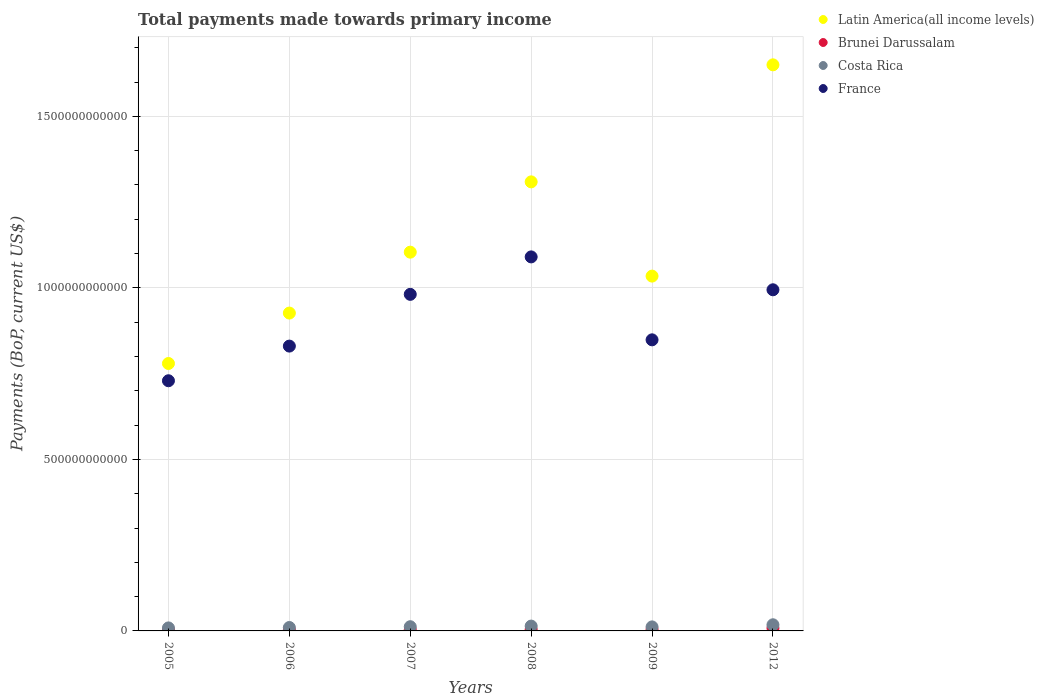How many different coloured dotlines are there?
Keep it short and to the point. 4. What is the total payments made towards primary income in Latin America(all income levels) in 2005?
Provide a short and direct response. 7.80e+11. Across all years, what is the maximum total payments made towards primary income in Brunei Darussalam?
Your response must be concise. 8.18e+09. Across all years, what is the minimum total payments made towards primary income in Brunei Darussalam?
Make the answer very short. 2.71e+09. In which year was the total payments made towards primary income in Costa Rica minimum?
Your answer should be compact. 2005. What is the total total payments made towards primary income in Costa Rica in the graph?
Offer a terse response. 7.48e+1. What is the difference between the total payments made towards primary income in Costa Rica in 2005 and that in 2006?
Provide a succinct answer. -1.19e+09. What is the difference between the total payments made towards primary income in Costa Rica in 2009 and the total payments made towards primary income in France in 2007?
Provide a short and direct response. -9.69e+11. What is the average total payments made towards primary income in Brunei Darussalam per year?
Ensure brevity in your answer.  4.31e+09. In the year 2006, what is the difference between the total payments made towards primary income in France and total payments made towards primary income in Costa Rica?
Provide a short and direct response. 8.20e+11. In how many years, is the total payments made towards primary income in Latin America(all income levels) greater than 900000000000 US$?
Give a very brief answer. 5. What is the ratio of the total payments made towards primary income in Costa Rica in 2007 to that in 2009?
Offer a terse response. 1.05. What is the difference between the highest and the second highest total payments made towards primary income in Costa Rica?
Give a very brief answer. 3.85e+09. What is the difference between the highest and the lowest total payments made towards primary income in France?
Offer a very short reply. 3.61e+11. Is it the case that in every year, the sum of the total payments made towards primary income in Costa Rica and total payments made towards primary income in Brunei Darussalam  is greater than the total payments made towards primary income in Latin America(all income levels)?
Your answer should be very brief. No. Does the total payments made towards primary income in France monotonically increase over the years?
Your answer should be very brief. No. Is the total payments made towards primary income in Latin America(all income levels) strictly greater than the total payments made towards primary income in Costa Rica over the years?
Keep it short and to the point. Yes. Is the total payments made towards primary income in France strictly less than the total payments made towards primary income in Latin America(all income levels) over the years?
Give a very brief answer. Yes. How many years are there in the graph?
Make the answer very short. 6. What is the difference between two consecutive major ticks on the Y-axis?
Offer a very short reply. 5.00e+11. Does the graph contain grids?
Keep it short and to the point. Yes. Where does the legend appear in the graph?
Keep it short and to the point. Top right. How are the legend labels stacked?
Your answer should be compact. Vertical. What is the title of the graph?
Keep it short and to the point. Total payments made towards primary income. Does "Rwanda" appear as one of the legend labels in the graph?
Offer a terse response. No. What is the label or title of the X-axis?
Make the answer very short. Years. What is the label or title of the Y-axis?
Ensure brevity in your answer.  Payments (BoP, current US$). What is the Payments (BoP, current US$) of Latin America(all income levels) in 2005?
Your answer should be compact. 7.80e+11. What is the Payments (BoP, current US$) of Brunei Darussalam in 2005?
Make the answer very short. 2.71e+09. What is the Payments (BoP, current US$) of Costa Rica in 2005?
Make the answer very short. 8.79e+09. What is the Payments (BoP, current US$) in France in 2005?
Keep it short and to the point. 7.29e+11. What is the Payments (BoP, current US$) of Latin America(all income levels) in 2006?
Provide a short and direct response. 9.27e+11. What is the Payments (BoP, current US$) in Brunei Darussalam in 2006?
Make the answer very short. 2.98e+09. What is the Payments (BoP, current US$) of Costa Rica in 2006?
Your answer should be compact. 9.98e+09. What is the Payments (BoP, current US$) in France in 2006?
Your answer should be compact. 8.30e+11. What is the Payments (BoP, current US$) in Latin America(all income levels) in 2007?
Your answer should be very brief. 1.10e+12. What is the Payments (BoP, current US$) of Brunei Darussalam in 2007?
Offer a terse response. 3.51e+09. What is the Payments (BoP, current US$) of Costa Rica in 2007?
Give a very brief answer. 1.23e+1. What is the Payments (BoP, current US$) in France in 2007?
Your response must be concise. 9.81e+11. What is the Payments (BoP, current US$) in Latin America(all income levels) in 2008?
Your answer should be compact. 1.31e+12. What is the Payments (BoP, current US$) in Brunei Darussalam in 2008?
Ensure brevity in your answer.  4.51e+09. What is the Payments (BoP, current US$) in Costa Rica in 2008?
Provide a succinct answer. 1.41e+1. What is the Payments (BoP, current US$) in France in 2008?
Provide a short and direct response. 1.09e+12. What is the Payments (BoP, current US$) in Latin America(all income levels) in 2009?
Your answer should be very brief. 1.03e+12. What is the Payments (BoP, current US$) in Brunei Darussalam in 2009?
Ensure brevity in your answer.  3.98e+09. What is the Payments (BoP, current US$) of Costa Rica in 2009?
Your answer should be very brief. 1.17e+1. What is the Payments (BoP, current US$) in France in 2009?
Offer a terse response. 8.49e+11. What is the Payments (BoP, current US$) in Latin America(all income levels) in 2012?
Give a very brief answer. 1.65e+12. What is the Payments (BoP, current US$) of Brunei Darussalam in 2012?
Offer a very short reply. 8.18e+09. What is the Payments (BoP, current US$) of Costa Rica in 2012?
Keep it short and to the point. 1.79e+1. What is the Payments (BoP, current US$) in France in 2012?
Offer a terse response. 9.95e+11. Across all years, what is the maximum Payments (BoP, current US$) in Latin America(all income levels)?
Give a very brief answer. 1.65e+12. Across all years, what is the maximum Payments (BoP, current US$) of Brunei Darussalam?
Your answer should be compact. 8.18e+09. Across all years, what is the maximum Payments (BoP, current US$) of Costa Rica?
Offer a terse response. 1.79e+1. Across all years, what is the maximum Payments (BoP, current US$) of France?
Offer a terse response. 1.09e+12. Across all years, what is the minimum Payments (BoP, current US$) in Latin America(all income levels)?
Ensure brevity in your answer.  7.80e+11. Across all years, what is the minimum Payments (BoP, current US$) of Brunei Darussalam?
Your response must be concise. 2.71e+09. Across all years, what is the minimum Payments (BoP, current US$) in Costa Rica?
Offer a terse response. 8.79e+09. Across all years, what is the minimum Payments (BoP, current US$) of France?
Your answer should be very brief. 7.29e+11. What is the total Payments (BoP, current US$) in Latin America(all income levels) in the graph?
Make the answer very short. 6.80e+12. What is the total Payments (BoP, current US$) of Brunei Darussalam in the graph?
Ensure brevity in your answer.  2.59e+1. What is the total Payments (BoP, current US$) of Costa Rica in the graph?
Make the answer very short. 7.48e+1. What is the total Payments (BoP, current US$) of France in the graph?
Make the answer very short. 5.47e+12. What is the difference between the Payments (BoP, current US$) in Latin America(all income levels) in 2005 and that in 2006?
Offer a terse response. -1.47e+11. What is the difference between the Payments (BoP, current US$) in Brunei Darussalam in 2005 and that in 2006?
Make the answer very short. -2.72e+08. What is the difference between the Payments (BoP, current US$) of Costa Rica in 2005 and that in 2006?
Provide a short and direct response. -1.19e+09. What is the difference between the Payments (BoP, current US$) of France in 2005 and that in 2006?
Your answer should be compact. -1.01e+11. What is the difference between the Payments (BoP, current US$) of Latin America(all income levels) in 2005 and that in 2007?
Offer a terse response. -3.25e+11. What is the difference between the Payments (BoP, current US$) in Brunei Darussalam in 2005 and that in 2007?
Your answer should be very brief. -8.03e+08. What is the difference between the Payments (BoP, current US$) of Costa Rica in 2005 and that in 2007?
Provide a succinct answer. -3.51e+09. What is the difference between the Payments (BoP, current US$) of France in 2005 and that in 2007?
Your response must be concise. -2.52e+11. What is the difference between the Payments (BoP, current US$) in Latin America(all income levels) in 2005 and that in 2008?
Your answer should be very brief. -5.29e+11. What is the difference between the Payments (BoP, current US$) in Brunei Darussalam in 2005 and that in 2008?
Give a very brief answer. -1.80e+09. What is the difference between the Payments (BoP, current US$) in Costa Rica in 2005 and that in 2008?
Your answer should be very brief. -5.31e+09. What is the difference between the Payments (BoP, current US$) in France in 2005 and that in 2008?
Offer a terse response. -3.61e+11. What is the difference between the Payments (BoP, current US$) in Latin America(all income levels) in 2005 and that in 2009?
Provide a succinct answer. -2.55e+11. What is the difference between the Payments (BoP, current US$) of Brunei Darussalam in 2005 and that in 2009?
Your answer should be very brief. -1.27e+09. What is the difference between the Payments (BoP, current US$) in Costa Rica in 2005 and that in 2009?
Give a very brief answer. -2.93e+09. What is the difference between the Payments (BoP, current US$) of France in 2005 and that in 2009?
Provide a succinct answer. -1.19e+11. What is the difference between the Payments (BoP, current US$) in Latin America(all income levels) in 2005 and that in 2012?
Offer a terse response. -8.71e+11. What is the difference between the Payments (BoP, current US$) in Brunei Darussalam in 2005 and that in 2012?
Ensure brevity in your answer.  -5.47e+09. What is the difference between the Payments (BoP, current US$) in Costa Rica in 2005 and that in 2012?
Your answer should be compact. -9.15e+09. What is the difference between the Payments (BoP, current US$) in France in 2005 and that in 2012?
Make the answer very short. -2.65e+11. What is the difference between the Payments (BoP, current US$) of Latin America(all income levels) in 2006 and that in 2007?
Offer a terse response. -1.78e+11. What is the difference between the Payments (BoP, current US$) in Brunei Darussalam in 2006 and that in 2007?
Make the answer very short. -5.30e+08. What is the difference between the Payments (BoP, current US$) of Costa Rica in 2006 and that in 2007?
Your answer should be compact. -2.32e+09. What is the difference between the Payments (BoP, current US$) of France in 2006 and that in 2007?
Make the answer very short. -1.51e+11. What is the difference between the Payments (BoP, current US$) in Latin America(all income levels) in 2006 and that in 2008?
Provide a short and direct response. -3.82e+11. What is the difference between the Payments (BoP, current US$) of Brunei Darussalam in 2006 and that in 2008?
Ensure brevity in your answer.  -1.52e+09. What is the difference between the Payments (BoP, current US$) in Costa Rica in 2006 and that in 2008?
Offer a very short reply. -4.12e+09. What is the difference between the Payments (BoP, current US$) in France in 2006 and that in 2008?
Your response must be concise. -2.60e+11. What is the difference between the Payments (BoP, current US$) in Latin America(all income levels) in 2006 and that in 2009?
Keep it short and to the point. -1.08e+11. What is the difference between the Payments (BoP, current US$) in Brunei Darussalam in 2006 and that in 2009?
Offer a terse response. -9.96e+08. What is the difference between the Payments (BoP, current US$) in Costa Rica in 2006 and that in 2009?
Your answer should be compact. -1.74e+09. What is the difference between the Payments (BoP, current US$) of France in 2006 and that in 2009?
Offer a terse response. -1.83e+1. What is the difference between the Payments (BoP, current US$) of Latin America(all income levels) in 2006 and that in 2012?
Provide a short and direct response. -7.24e+11. What is the difference between the Payments (BoP, current US$) in Brunei Darussalam in 2006 and that in 2012?
Offer a very short reply. -5.20e+09. What is the difference between the Payments (BoP, current US$) in Costa Rica in 2006 and that in 2012?
Make the answer very short. -7.96e+09. What is the difference between the Payments (BoP, current US$) of France in 2006 and that in 2012?
Your answer should be compact. -1.64e+11. What is the difference between the Payments (BoP, current US$) in Latin America(all income levels) in 2007 and that in 2008?
Your answer should be very brief. -2.05e+11. What is the difference between the Payments (BoP, current US$) in Brunei Darussalam in 2007 and that in 2008?
Make the answer very short. -9.95e+08. What is the difference between the Payments (BoP, current US$) of Costa Rica in 2007 and that in 2008?
Your response must be concise. -1.79e+09. What is the difference between the Payments (BoP, current US$) in France in 2007 and that in 2008?
Give a very brief answer. -1.09e+11. What is the difference between the Payments (BoP, current US$) of Latin America(all income levels) in 2007 and that in 2009?
Your response must be concise. 6.98e+1. What is the difference between the Payments (BoP, current US$) of Brunei Darussalam in 2007 and that in 2009?
Provide a short and direct response. -4.66e+08. What is the difference between the Payments (BoP, current US$) of Costa Rica in 2007 and that in 2009?
Provide a short and direct response. 5.80e+08. What is the difference between the Payments (BoP, current US$) of France in 2007 and that in 2009?
Your answer should be very brief. 1.33e+11. What is the difference between the Payments (BoP, current US$) in Latin America(all income levels) in 2007 and that in 2012?
Keep it short and to the point. -5.46e+11. What is the difference between the Payments (BoP, current US$) in Brunei Darussalam in 2007 and that in 2012?
Keep it short and to the point. -4.67e+09. What is the difference between the Payments (BoP, current US$) of Costa Rica in 2007 and that in 2012?
Offer a very short reply. -5.64e+09. What is the difference between the Payments (BoP, current US$) in France in 2007 and that in 2012?
Your answer should be compact. -1.33e+1. What is the difference between the Payments (BoP, current US$) in Latin America(all income levels) in 2008 and that in 2009?
Provide a short and direct response. 2.75e+11. What is the difference between the Payments (BoP, current US$) in Brunei Darussalam in 2008 and that in 2009?
Give a very brief answer. 5.28e+08. What is the difference between the Payments (BoP, current US$) of Costa Rica in 2008 and that in 2009?
Ensure brevity in your answer.  2.37e+09. What is the difference between the Payments (BoP, current US$) of France in 2008 and that in 2009?
Your response must be concise. 2.42e+11. What is the difference between the Payments (BoP, current US$) of Latin America(all income levels) in 2008 and that in 2012?
Your answer should be very brief. -3.41e+11. What is the difference between the Payments (BoP, current US$) of Brunei Darussalam in 2008 and that in 2012?
Your answer should be compact. -3.67e+09. What is the difference between the Payments (BoP, current US$) in Costa Rica in 2008 and that in 2012?
Provide a short and direct response. -3.85e+09. What is the difference between the Payments (BoP, current US$) in France in 2008 and that in 2012?
Provide a succinct answer. 9.59e+1. What is the difference between the Payments (BoP, current US$) in Latin America(all income levels) in 2009 and that in 2012?
Give a very brief answer. -6.16e+11. What is the difference between the Payments (BoP, current US$) in Brunei Darussalam in 2009 and that in 2012?
Keep it short and to the point. -4.20e+09. What is the difference between the Payments (BoP, current US$) in Costa Rica in 2009 and that in 2012?
Provide a short and direct response. -6.22e+09. What is the difference between the Payments (BoP, current US$) of France in 2009 and that in 2012?
Offer a very short reply. -1.46e+11. What is the difference between the Payments (BoP, current US$) in Latin America(all income levels) in 2005 and the Payments (BoP, current US$) in Brunei Darussalam in 2006?
Give a very brief answer. 7.77e+11. What is the difference between the Payments (BoP, current US$) of Latin America(all income levels) in 2005 and the Payments (BoP, current US$) of Costa Rica in 2006?
Ensure brevity in your answer.  7.70e+11. What is the difference between the Payments (BoP, current US$) in Latin America(all income levels) in 2005 and the Payments (BoP, current US$) in France in 2006?
Your answer should be compact. -5.07e+1. What is the difference between the Payments (BoP, current US$) in Brunei Darussalam in 2005 and the Payments (BoP, current US$) in Costa Rica in 2006?
Provide a short and direct response. -7.26e+09. What is the difference between the Payments (BoP, current US$) of Brunei Darussalam in 2005 and the Payments (BoP, current US$) of France in 2006?
Ensure brevity in your answer.  -8.28e+11. What is the difference between the Payments (BoP, current US$) in Costa Rica in 2005 and the Payments (BoP, current US$) in France in 2006?
Offer a very short reply. -8.22e+11. What is the difference between the Payments (BoP, current US$) of Latin America(all income levels) in 2005 and the Payments (BoP, current US$) of Brunei Darussalam in 2007?
Make the answer very short. 7.76e+11. What is the difference between the Payments (BoP, current US$) of Latin America(all income levels) in 2005 and the Payments (BoP, current US$) of Costa Rica in 2007?
Provide a succinct answer. 7.67e+11. What is the difference between the Payments (BoP, current US$) of Latin America(all income levels) in 2005 and the Payments (BoP, current US$) of France in 2007?
Provide a short and direct response. -2.02e+11. What is the difference between the Payments (BoP, current US$) in Brunei Darussalam in 2005 and the Payments (BoP, current US$) in Costa Rica in 2007?
Ensure brevity in your answer.  -9.59e+09. What is the difference between the Payments (BoP, current US$) of Brunei Darussalam in 2005 and the Payments (BoP, current US$) of France in 2007?
Your response must be concise. -9.78e+11. What is the difference between the Payments (BoP, current US$) in Costa Rica in 2005 and the Payments (BoP, current US$) in France in 2007?
Your answer should be compact. -9.72e+11. What is the difference between the Payments (BoP, current US$) of Latin America(all income levels) in 2005 and the Payments (BoP, current US$) of Brunei Darussalam in 2008?
Make the answer very short. 7.75e+11. What is the difference between the Payments (BoP, current US$) in Latin America(all income levels) in 2005 and the Payments (BoP, current US$) in Costa Rica in 2008?
Ensure brevity in your answer.  7.66e+11. What is the difference between the Payments (BoP, current US$) in Latin America(all income levels) in 2005 and the Payments (BoP, current US$) in France in 2008?
Your answer should be very brief. -3.11e+11. What is the difference between the Payments (BoP, current US$) of Brunei Darussalam in 2005 and the Payments (BoP, current US$) of Costa Rica in 2008?
Make the answer very short. -1.14e+1. What is the difference between the Payments (BoP, current US$) in Brunei Darussalam in 2005 and the Payments (BoP, current US$) in France in 2008?
Provide a succinct answer. -1.09e+12. What is the difference between the Payments (BoP, current US$) of Costa Rica in 2005 and the Payments (BoP, current US$) of France in 2008?
Your response must be concise. -1.08e+12. What is the difference between the Payments (BoP, current US$) of Latin America(all income levels) in 2005 and the Payments (BoP, current US$) of Brunei Darussalam in 2009?
Keep it short and to the point. 7.76e+11. What is the difference between the Payments (BoP, current US$) of Latin America(all income levels) in 2005 and the Payments (BoP, current US$) of Costa Rica in 2009?
Provide a short and direct response. 7.68e+11. What is the difference between the Payments (BoP, current US$) of Latin America(all income levels) in 2005 and the Payments (BoP, current US$) of France in 2009?
Ensure brevity in your answer.  -6.90e+1. What is the difference between the Payments (BoP, current US$) of Brunei Darussalam in 2005 and the Payments (BoP, current US$) of Costa Rica in 2009?
Your response must be concise. -9.01e+09. What is the difference between the Payments (BoP, current US$) in Brunei Darussalam in 2005 and the Payments (BoP, current US$) in France in 2009?
Offer a terse response. -8.46e+11. What is the difference between the Payments (BoP, current US$) of Costa Rica in 2005 and the Payments (BoP, current US$) of France in 2009?
Make the answer very short. -8.40e+11. What is the difference between the Payments (BoP, current US$) in Latin America(all income levels) in 2005 and the Payments (BoP, current US$) in Brunei Darussalam in 2012?
Your answer should be compact. 7.71e+11. What is the difference between the Payments (BoP, current US$) of Latin America(all income levels) in 2005 and the Payments (BoP, current US$) of Costa Rica in 2012?
Give a very brief answer. 7.62e+11. What is the difference between the Payments (BoP, current US$) in Latin America(all income levels) in 2005 and the Payments (BoP, current US$) in France in 2012?
Offer a terse response. -2.15e+11. What is the difference between the Payments (BoP, current US$) of Brunei Darussalam in 2005 and the Payments (BoP, current US$) of Costa Rica in 2012?
Offer a very short reply. -1.52e+1. What is the difference between the Payments (BoP, current US$) of Brunei Darussalam in 2005 and the Payments (BoP, current US$) of France in 2012?
Ensure brevity in your answer.  -9.92e+11. What is the difference between the Payments (BoP, current US$) in Costa Rica in 2005 and the Payments (BoP, current US$) in France in 2012?
Make the answer very short. -9.86e+11. What is the difference between the Payments (BoP, current US$) in Latin America(all income levels) in 2006 and the Payments (BoP, current US$) in Brunei Darussalam in 2007?
Give a very brief answer. 9.23e+11. What is the difference between the Payments (BoP, current US$) of Latin America(all income levels) in 2006 and the Payments (BoP, current US$) of Costa Rica in 2007?
Provide a succinct answer. 9.14e+11. What is the difference between the Payments (BoP, current US$) in Latin America(all income levels) in 2006 and the Payments (BoP, current US$) in France in 2007?
Offer a terse response. -5.45e+1. What is the difference between the Payments (BoP, current US$) of Brunei Darussalam in 2006 and the Payments (BoP, current US$) of Costa Rica in 2007?
Your response must be concise. -9.32e+09. What is the difference between the Payments (BoP, current US$) of Brunei Darussalam in 2006 and the Payments (BoP, current US$) of France in 2007?
Offer a terse response. -9.78e+11. What is the difference between the Payments (BoP, current US$) of Costa Rica in 2006 and the Payments (BoP, current US$) of France in 2007?
Give a very brief answer. -9.71e+11. What is the difference between the Payments (BoP, current US$) in Latin America(all income levels) in 2006 and the Payments (BoP, current US$) in Brunei Darussalam in 2008?
Give a very brief answer. 9.22e+11. What is the difference between the Payments (BoP, current US$) of Latin America(all income levels) in 2006 and the Payments (BoP, current US$) of Costa Rica in 2008?
Offer a terse response. 9.13e+11. What is the difference between the Payments (BoP, current US$) of Latin America(all income levels) in 2006 and the Payments (BoP, current US$) of France in 2008?
Your answer should be very brief. -1.64e+11. What is the difference between the Payments (BoP, current US$) in Brunei Darussalam in 2006 and the Payments (BoP, current US$) in Costa Rica in 2008?
Your answer should be compact. -1.11e+1. What is the difference between the Payments (BoP, current US$) in Brunei Darussalam in 2006 and the Payments (BoP, current US$) in France in 2008?
Your answer should be very brief. -1.09e+12. What is the difference between the Payments (BoP, current US$) of Costa Rica in 2006 and the Payments (BoP, current US$) of France in 2008?
Your answer should be very brief. -1.08e+12. What is the difference between the Payments (BoP, current US$) in Latin America(all income levels) in 2006 and the Payments (BoP, current US$) in Brunei Darussalam in 2009?
Ensure brevity in your answer.  9.23e+11. What is the difference between the Payments (BoP, current US$) of Latin America(all income levels) in 2006 and the Payments (BoP, current US$) of Costa Rica in 2009?
Give a very brief answer. 9.15e+11. What is the difference between the Payments (BoP, current US$) in Latin America(all income levels) in 2006 and the Payments (BoP, current US$) in France in 2009?
Offer a terse response. 7.80e+1. What is the difference between the Payments (BoP, current US$) of Brunei Darussalam in 2006 and the Payments (BoP, current US$) of Costa Rica in 2009?
Provide a short and direct response. -8.74e+09. What is the difference between the Payments (BoP, current US$) in Brunei Darussalam in 2006 and the Payments (BoP, current US$) in France in 2009?
Offer a terse response. -8.46e+11. What is the difference between the Payments (BoP, current US$) in Costa Rica in 2006 and the Payments (BoP, current US$) in France in 2009?
Make the answer very short. -8.39e+11. What is the difference between the Payments (BoP, current US$) of Latin America(all income levels) in 2006 and the Payments (BoP, current US$) of Brunei Darussalam in 2012?
Make the answer very short. 9.18e+11. What is the difference between the Payments (BoP, current US$) of Latin America(all income levels) in 2006 and the Payments (BoP, current US$) of Costa Rica in 2012?
Offer a terse response. 9.09e+11. What is the difference between the Payments (BoP, current US$) of Latin America(all income levels) in 2006 and the Payments (BoP, current US$) of France in 2012?
Your answer should be compact. -6.79e+1. What is the difference between the Payments (BoP, current US$) of Brunei Darussalam in 2006 and the Payments (BoP, current US$) of Costa Rica in 2012?
Ensure brevity in your answer.  -1.50e+1. What is the difference between the Payments (BoP, current US$) of Brunei Darussalam in 2006 and the Payments (BoP, current US$) of France in 2012?
Your response must be concise. -9.92e+11. What is the difference between the Payments (BoP, current US$) in Costa Rica in 2006 and the Payments (BoP, current US$) in France in 2012?
Offer a terse response. -9.85e+11. What is the difference between the Payments (BoP, current US$) in Latin America(all income levels) in 2007 and the Payments (BoP, current US$) in Brunei Darussalam in 2008?
Your response must be concise. 1.10e+12. What is the difference between the Payments (BoP, current US$) of Latin America(all income levels) in 2007 and the Payments (BoP, current US$) of Costa Rica in 2008?
Ensure brevity in your answer.  1.09e+12. What is the difference between the Payments (BoP, current US$) in Latin America(all income levels) in 2007 and the Payments (BoP, current US$) in France in 2008?
Make the answer very short. 1.38e+1. What is the difference between the Payments (BoP, current US$) of Brunei Darussalam in 2007 and the Payments (BoP, current US$) of Costa Rica in 2008?
Offer a very short reply. -1.06e+1. What is the difference between the Payments (BoP, current US$) of Brunei Darussalam in 2007 and the Payments (BoP, current US$) of France in 2008?
Your answer should be compact. -1.09e+12. What is the difference between the Payments (BoP, current US$) of Costa Rica in 2007 and the Payments (BoP, current US$) of France in 2008?
Ensure brevity in your answer.  -1.08e+12. What is the difference between the Payments (BoP, current US$) in Latin America(all income levels) in 2007 and the Payments (BoP, current US$) in Brunei Darussalam in 2009?
Offer a terse response. 1.10e+12. What is the difference between the Payments (BoP, current US$) of Latin America(all income levels) in 2007 and the Payments (BoP, current US$) of Costa Rica in 2009?
Keep it short and to the point. 1.09e+12. What is the difference between the Payments (BoP, current US$) in Latin America(all income levels) in 2007 and the Payments (BoP, current US$) in France in 2009?
Keep it short and to the point. 2.56e+11. What is the difference between the Payments (BoP, current US$) in Brunei Darussalam in 2007 and the Payments (BoP, current US$) in Costa Rica in 2009?
Offer a terse response. -8.21e+09. What is the difference between the Payments (BoP, current US$) of Brunei Darussalam in 2007 and the Payments (BoP, current US$) of France in 2009?
Your answer should be compact. -8.45e+11. What is the difference between the Payments (BoP, current US$) of Costa Rica in 2007 and the Payments (BoP, current US$) of France in 2009?
Provide a succinct answer. -8.36e+11. What is the difference between the Payments (BoP, current US$) in Latin America(all income levels) in 2007 and the Payments (BoP, current US$) in Brunei Darussalam in 2012?
Provide a short and direct response. 1.10e+12. What is the difference between the Payments (BoP, current US$) of Latin America(all income levels) in 2007 and the Payments (BoP, current US$) of Costa Rica in 2012?
Provide a short and direct response. 1.09e+12. What is the difference between the Payments (BoP, current US$) in Latin America(all income levels) in 2007 and the Payments (BoP, current US$) in France in 2012?
Offer a very short reply. 1.10e+11. What is the difference between the Payments (BoP, current US$) in Brunei Darussalam in 2007 and the Payments (BoP, current US$) in Costa Rica in 2012?
Make the answer very short. -1.44e+1. What is the difference between the Payments (BoP, current US$) of Brunei Darussalam in 2007 and the Payments (BoP, current US$) of France in 2012?
Make the answer very short. -9.91e+11. What is the difference between the Payments (BoP, current US$) of Costa Rica in 2007 and the Payments (BoP, current US$) of France in 2012?
Offer a very short reply. -9.82e+11. What is the difference between the Payments (BoP, current US$) in Latin America(all income levels) in 2008 and the Payments (BoP, current US$) in Brunei Darussalam in 2009?
Your answer should be very brief. 1.31e+12. What is the difference between the Payments (BoP, current US$) of Latin America(all income levels) in 2008 and the Payments (BoP, current US$) of Costa Rica in 2009?
Keep it short and to the point. 1.30e+12. What is the difference between the Payments (BoP, current US$) of Latin America(all income levels) in 2008 and the Payments (BoP, current US$) of France in 2009?
Offer a very short reply. 4.61e+11. What is the difference between the Payments (BoP, current US$) of Brunei Darussalam in 2008 and the Payments (BoP, current US$) of Costa Rica in 2009?
Your answer should be very brief. -7.21e+09. What is the difference between the Payments (BoP, current US$) in Brunei Darussalam in 2008 and the Payments (BoP, current US$) in France in 2009?
Offer a very short reply. -8.44e+11. What is the difference between the Payments (BoP, current US$) of Costa Rica in 2008 and the Payments (BoP, current US$) of France in 2009?
Your answer should be very brief. -8.34e+11. What is the difference between the Payments (BoP, current US$) in Latin America(all income levels) in 2008 and the Payments (BoP, current US$) in Brunei Darussalam in 2012?
Make the answer very short. 1.30e+12. What is the difference between the Payments (BoP, current US$) of Latin America(all income levels) in 2008 and the Payments (BoP, current US$) of Costa Rica in 2012?
Give a very brief answer. 1.29e+12. What is the difference between the Payments (BoP, current US$) in Latin America(all income levels) in 2008 and the Payments (BoP, current US$) in France in 2012?
Ensure brevity in your answer.  3.15e+11. What is the difference between the Payments (BoP, current US$) in Brunei Darussalam in 2008 and the Payments (BoP, current US$) in Costa Rica in 2012?
Your response must be concise. -1.34e+1. What is the difference between the Payments (BoP, current US$) of Brunei Darussalam in 2008 and the Payments (BoP, current US$) of France in 2012?
Provide a short and direct response. -9.90e+11. What is the difference between the Payments (BoP, current US$) in Costa Rica in 2008 and the Payments (BoP, current US$) in France in 2012?
Your response must be concise. -9.80e+11. What is the difference between the Payments (BoP, current US$) of Latin America(all income levels) in 2009 and the Payments (BoP, current US$) of Brunei Darussalam in 2012?
Keep it short and to the point. 1.03e+12. What is the difference between the Payments (BoP, current US$) in Latin America(all income levels) in 2009 and the Payments (BoP, current US$) in Costa Rica in 2012?
Your answer should be compact. 1.02e+12. What is the difference between the Payments (BoP, current US$) in Latin America(all income levels) in 2009 and the Payments (BoP, current US$) in France in 2012?
Make the answer very short. 3.99e+1. What is the difference between the Payments (BoP, current US$) in Brunei Darussalam in 2009 and the Payments (BoP, current US$) in Costa Rica in 2012?
Keep it short and to the point. -1.40e+1. What is the difference between the Payments (BoP, current US$) of Brunei Darussalam in 2009 and the Payments (BoP, current US$) of France in 2012?
Provide a short and direct response. -9.91e+11. What is the difference between the Payments (BoP, current US$) of Costa Rica in 2009 and the Payments (BoP, current US$) of France in 2012?
Your answer should be very brief. -9.83e+11. What is the average Payments (BoP, current US$) in Latin America(all income levels) per year?
Your answer should be compact. 1.13e+12. What is the average Payments (BoP, current US$) of Brunei Darussalam per year?
Your response must be concise. 4.31e+09. What is the average Payments (BoP, current US$) of Costa Rica per year?
Make the answer very short. 1.25e+1. What is the average Payments (BoP, current US$) in France per year?
Ensure brevity in your answer.  9.12e+11. In the year 2005, what is the difference between the Payments (BoP, current US$) of Latin America(all income levels) and Payments (BoP, current US$) of Brunei Darussalam?
Offer a terse response. 7.77e+11. In the year 2005, what is the difference between the Payments (BoP, current US$) in Latin America(all income levels) and Payments (BoP, current US$) in Costa Rica?
Provide a short and direct response. 7.71e+11. In the year 2005, what is the difference between the Payments (BoP, current US$) of Latin America(all income levels) and Payments (BoP, current US$) of France?
Keep it short and to the point. 5.03e+1. In the year 2005, what is the difference between the Payments (BoP, current US$) of Brunei Darussalam and Payments (BoP, current US$) of Costa Rica?
Make the answer very short. -6.07e+09. In the year 2005, what is the difference between the Payments (BoP, current US$) in Brunei Darussalam and Payments (BoP, current US$) in France?
Offer a terse response. -7.27e+11. In the year 2005, what is the difference between the Payments (BoP, current US$) in Costa Rica and Payments (BoP, current US$) in France?
Your response must be concise. -7.21e+11. In the year 2006, what is the difference between the Payments (BoP, current US$) of Latin America(all income levels) and Payments (BoP, current US$) of Brunei Darussalam?
Your response must be concise. 9.24e+11. In the year 2006, what is the difference between the Payments (BoP, current US$) of Latin America(all income levels) and Payments (BoP, current US$) of Costa Rica?
Keep it short and to the point. 9.17e+11. In the year 2006, what is the difference between the Payments (BoP, current US$) in Latin America(all income levels) and Payments (BoP, current US$) in France?
Offer a very short reply. 9.63e+1. In the year 2006, what is the difference between the Payments (BoP, current US$) in Brunei Darussalam and Payments (BoP, current US$) in Costa Rica?
Ensure brevity in your answer.  -6.99e+09. In the year 2006, what is the difference between the Payments (BoP, current US$) in Brunei Darussalam and Payments (BoP, current US$) in France?
Keep it short and to the point. -8.27e+11. In the year 2006, what is the difference between the Payments (BoP, current US$) of Costa Rica and Payments (BoP, current US$) of France?
Give a very brief answer. -8.20e+11. In the year 2007, what is the difference between the Payments (BoP, current US$) in Latin America(all income levels) and Payments (BoP, current US$) in Brunei Darussalam?
Your answer should be very brief. 1.10e+12. In the year 2007, what is the difference between the Payments (BoP, current US$) of Latin America(all income levels) and Payments (BoP, current US$) of Costa Rica?
Make the answer very short. 1.09e+12. In the year 2007, what is the difference between the Payments (BoP, current US$) in Latin America(all income levels) and Payments (BoP, current US$) in France?
Provide a succinct answer. 1.23e+11. In the year 2007, what is the difference between the Payments (BoP, current US$) in Brunei Darussalam and Payments (BoP, current US$) in Costa Rica?
Offer a very short reply. -8.79e+09. In the year 2007, what is the difference between the Payments (BoP, current US$) in Brunei Darussalam and Payments (BoP, current US$) in France?
Your answer should be compact. -9.78e+11. In the year 2007, what is the difference between the Payments (BoP, current US$) in Costa Rica and Payments (BoP, current US$) in France?
Your response must be concise. -9.69e+11. In the year 2008, what is the difference between the Payments (BoP, current US$) of Latin America(all income levels) and Payments (BoP, current US$) of Brunei Darussalam?
Ensure brevity in your answer.  1.30e+12. In the year 2008, what is the difference between the Payments (BoP, current US$) of Latin America(all income levels) and Payments (BoP, current US$) of Costa Rica?
Keep it short and to the point. 1.30e+12. In the year 2008, what is the difference between the Payments (BoP, current US$) in Latin America(all income levels) and Payments (BoP, current US$) in France?
Offer a terse response. 2.19e+11. In the year 2008, what is the difference between the Payments (BoP, current US$) in Brunei Darussalam and Payments (BoP, current US$) in Costa Rica?
Your answer should be very brief. -9.58e+09. In the year 2008, what is the difference between the Payments (BoP, current US$) in Brunei Darussalam and Payments (BoP, current US$) in France?
Offer a very short reply. -1.09e+12. In the year 2008, what is the difference between the Payments (BoP, current US$) of Costa Rica and Payments (BoP, current US$) of France?
Keep it short and to the point. -1.08e+12. In the year 2009, what is the difference between the Payments (BoP, current US$) of Latin America(all income levels) and Payments (BoP, current US$) of Brunei Darussalam?
Your response must be concise. 1.03e+12. In the year 2009, what is the difference between the Payments (BoP, current US$) of Latin America(all income levels) and Payments (BoP, current US$) of Costa Rica?
Offer a very short reply. 1.02e+12. In the year 2009, what is the difference between the Payments (BoP, current US$) of Latin America(all income levels) and Payments (BoP, current US$) of France?
Your answer should be very brief. 1.86e+11. In the year 2009, what is the difference between the Payments (BoP, current US$) in Brunei Darussalam and Payments (BoP, current US$) in Costa Rica?
Give a very brief answer. -7.74e+09. In the year 2009, what is the difference between the Payments (BoP, current US$) in Brunei Darussalam and Payments (BoP, current US$) in France?
Offer a terse response. -8.45e+11. In the year 2009, what is the difference between the Payments (BoP, current US$) in Costa Rica and Payments (BoP, current US$) in France?
Your response must be concise. -8.37e+11. In the year 2012, what is the difference between the Payments (BoP, current US$) in Latin America(all income levels) and Payments (BoP, current US$) in Brunei Darussalam?
Ensure brevity in your answer.  1.64e+12. In the year 2012, what is the difference between the Payments (BoP, current US$) in Latin America(all income levels) and Payments (BoP, current US$) in Costa Rica?
Make the answer very short. 1.63e+12. In the year 2012, what is the difference between the Payments (BoP, current US$) of Latin America(all income levels) and Payments (BoP, current US$) of France?
Keep it short and to the point. 6.56e+11. In the year 2012, what is the difference between the Payments (BoP, current US$) of Brunei Darussalam and Payments (BoP, current US$) of Costa Rica?
Keep it short and to the point. -9.76e+09. In the year 2012, what is the difference between the Payments (BoP, current US$) of Brunei Darussalam and Payments (BoP, current US$) of France?
Offer a terse response. -9.86e+11. In the year 2012, what is the difference between the Payments (BoP, current US$) in Costa Rica and Payments (BoP, current US$) in France?
Give a very brief answer. -9.77e+11. What is the ratio of the Payments (BoP, current US$) in Latin America(all income levels) in 2005 to that in 2006?
Offer a terse response. 0.84. What is the ratio of the Payments (BoP, current US$) in Brunei Darussalam in 2005 to that in 2006?
Your answer should be very brief. 0.91. What is the ratio of the Payments (BoP, current US$) in Costa Rica in 2005 to that in 2006?
Give a very brief answer. 0.88. What is the ratio of the Payments (BoP, current US$) in France in 2005 to that in 2006?
Offer a terse response. 0.88. What is the ratio of the Payments (BoP, current US$) in Latin America(all income levels) in 2005 to that in 2007?
Provide a succinct answer. 0.71. What is the ratio of the Payments (BoP, current US$) in Brunei Darussalam in 2005 to that in 2007?
Provide a short and direct response. 0.77. What is the ratio of the Payments (BoP, current US$) of Costa Rica in 2005 to that in 2007?
Your response must be concise. 0.71. What is the ratio of the Payments (BoP, current US$) of France in 2005 to that in 2007?
Keep it short and to the point. 0.74. What is the ratio of the Payments (BoP, current US$) of Latin America(all income levels) in 2005 to that in 2008?
Your answer should be compact. 0.6. What is the ratio of the Payments (BoP, current US$) of Brunei Darussalam in 2005 to that in 2008?
Your response must be concise. 0.6. What is the ratio of the Payments (BoP, current US$) in Costa Rica in 2005 to that in 2008?
Your answer should be compact. 0.62. What is the ratio of the Payments (BoP, current US$) of France in 2005 to that in 2008?
Give a very brief answer. 0.67. What is the ratio of the Payments (BoP, current US$) in Latin America(all income levels) in 2005 to that in 2009?
Provide a succinct answer. 0.75. What is the ratio of the Payments (BoP, current US$) in Brunei Darussalam in 2005 to that in 2009?
Ensure brevity in your answer.  0.68. What is the ratio of the Payments (BoP, current US$) of Costa Rica in 2005 to that in 2009?
Your answer should be compact. 0.75. What is the ratio of the Payments (BoP, current US$) in France in 2005 to that in 2009?
Ensure brevity in your answer.  0.86. What is the ratio of the Payments (BoP, current US$) of Latin America(all income levels) in 2005 to that in 2012?
Ensure brevity in your answer.  0.47. What is the ratio of the Payments (BoP, current US$) in Brunei Darussalam in 2005 to that in 2012?
Offer a terse response. 0.33. What is the ratio of the Payments (BoP, current US$) of Costa Rica in 2005 to that in 2012?
Provide a succinct answer. 0.49. What is the ratio of the Payments (BoP, current US$) of France in 2005 to that in 2012?
Keep it short and to the point. 0.73. What is the ratio of the Payments (BoP, current US$) of Latin America(all income levels) in 2006 to that in 2007?
Provide a succinct answer. 0.84. What is the ratio of the Payments (BoP, current US$) of Brunei Darussalam in 2006 to that in 2007?
Provide a short and direct response. 0.85. What is the ratio of the Payments (BoP, current US$) in Costa Rica in 2006 to that in 2007?
Keep it short and to the point. 0.81. What is the ratio of the Payments (BoP, current US$) in France in 2006 to that in 2007?
Offer a terse response. 0.85. What is the ratio of the Payments (BoP, current US$) in Latin America(all income levels) in 2006 to that in 2008?
Keep it short and to the point. 0.71. What is the ratio of the Payments (BoP, current US$) of Brunei Darussalam in 2006 to that in 2008?
Ensure brevity in your answer.  0.66. What is the ratio of the Payments (BoP, current US$) in Costa Rica in 2006 to that in 2008?
Keep it short and to the point. 0.71. What is the ratio of the Payments (BoP, current US$) in France in 2006 to that in 2008?
Offer a terse response. 0.76. What is the ratio of the Payments (BoP, current US$) of Latin America(all income levels) in 2006 to that in 2009?
Make the answer very short. 0.9. What is the ratio of the Payments (BoP, current US$) of Brunei Darussalam in 2006 to that in 2009?
Your response must be concise. 0.75. What is the ratio of the Payments (BoP, current US$) in Costa Rica in 2006 to that in 2009?
Keep it short and to the point. 0.85. What is the ratio of the Payments (BoP, current US$) in France in 2006 to that in 2009?
Ensure brevity in your answer.  0.98. What is the ratio of the Payments (BoP, current US$) in Latin America(all income levels) in 2006 to that in 2012?
Provide a short and direct response. 0.56. What is the ratio of the Payments (BoP, current US$) in Brunei Darussalam in 2006 to that in 2012?
Make the answer very short. 0.36. What is the ratio of the Payments (BoP, current US$) of Costa Rica in 2006 to that in 2012?
Offer a very short reply. 0.56. What is the ratio of the Payments (BoP, current US$) in France in 2006 to that in 2012?
Your answer should be very brief. 0.83. What is the ratio of the Payments (BoP, current US$) in Latin America(all income levels) in 2007 to that in 2008?
Your answer should be very brief. 0.84. What is the ratio of the Payments (BoP, current US$) in Brunei Darussalam in 2007 to that in 2008?
Provide a succinct answer. 0.78. What is the ratio of the Payments (BoP, current US$) in Costa Rica in 2007 to that in 2008?
Keep it short and to the point. 0.87. What is the ratio of the Payments (BoP, current US$) in France in 2007 to that in 2008?
Keep it short and to the point. 0.9. What is the ratio of the Payments (BoP, current US$) in Latin America(all income levels) in 2007 to that in 2009?
Offer a very short reply. 1.07. What is the ratio of the Payments (BoP, current US$) in Brunei Darussalam in 2007 to that in 2009?
Ensure brevity in your answer.  0.88. What is the ratio of the Payments (BoP, current US$) in Costa Rica in 2007 to that in 2009?
Your answer should be compact. 1.05. What is the ratio of the Payments (BoP, current US$) of France in 2007 to that in 2009?
Provide a short and direct response. 1.16. What is the ratio of the Payments (BoP, current US$) of Latin America(all income levels) in 2007 to that in 2012?
Your answer should be compact. 0.67. What is the ratio of the Payments (BoP, current US$) of Brunei Darussalam in 2007 to that in 2012?
Your response must be concise. 0.43. What is the ratio of the Payments (BoP, current US$) of Costa Rica in 2007 to that in 2012?
Keep it short and to the point. 0.69. What is the ratio of the Payments (BoP, current US$) in France in 2007 to that in 2012?
Make the answer very short. 0.99. What is the ratio of the Payments (BoP, current US$) in Latin America(all income levels) in 2008 to that in 2009?
Provide a succinct answer. 1.27. What is the ratio of the Payments (BoP, current US$) of Brunei Darussalam in 2008 to that in 2009?
Your answer should be compact. 1.13. What is the ratio of the Payments (BoP, current US$) of Costa Rica in 2008 to that in 2009?
Provide a succinct answer. 1.2. What is the ratio of the Payments (BoP, current US$) of France in 2008 to that in 2009?
Keep it short and to the point. 1.28. What is the ratio of the Payments (BoP, current US$) of Latin America(all income levels) in 2008 to that in 2012?
Keep it short and to the point. 0.79. What is the ratio of the Payments (BoP, current US$) of Brunei Darussalam in 2008 to that in 2012?
Provide a short and direct response. 0.55. What is the ratio of the Payments (BoP, current US$) of Costa Rica in 2008 to that in 2012?
Your answer should be compact. 0.79. What is the ratio of the Payments (BoP, current US$) in France in 2008 to that in 2012?
Offer a very short reply. 1.1. What is the ratio of the Payments (BoP, current US$) in Latin America(all income levels) in 2009 to that in 2012?
Give a very brief answer. 0.63. What is the ratio of the Payments (BoP, current US$) of Brunei Darussalam in 2009 to that in 2012?
Provide a short and direct response. 0.49. What is the ratio of the Payments (BoP, current US$) of Costa Rica in 2009 to that in 2012?
Give a very brief answer. 0.65. What is the ratio of the Payments (BoP, current US$) of France in 2009 to that in 2012?
Ensure brevity in your answer.  0.85. What is the difference between the highest and the second highest Payments (BoP, current US$) of Latin America(all income levels)?
Give a very brief answer. 3.41e+11. What is the difference between the highest and the second highest Payments (BoP, current US$) in Brunei Darussalam?
Keep it short and to the point. 3.67e+09. What is the difference between the highest and the second highest Payments (BoP, current US$) in Costa Rica?
Your answer should be compact. 3.85e+09. What is the difference between the highest and the second highest Payments (BoP, current US$) in France?
Keep it short and to the point. 9.59e+1. What is the difference between the highest and the lowest Payments (BoP, current US$) in Latin America(all income levels)?
Keep it short and to the point. 8.71e+11. What is the difference between the highest and the lowest Payments (BoP, current US$) of Brunei Darussalam?
Ensure brevity in your answer.  5.47e+09. What is the difference between the highest and the lowest Payments (BoP, current US$) of Costa Rica?
Offer a very short reply. 9.15e+09. What is the difference between the highest and the lowest Payments (BoP, current US$) in France?
Your response must be concise. 3.61e+11. 